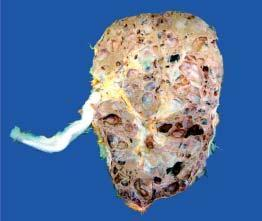what are the renal pelvis and calyces distorted due to?
Answer the question using a single word or phrase. Cystic change 